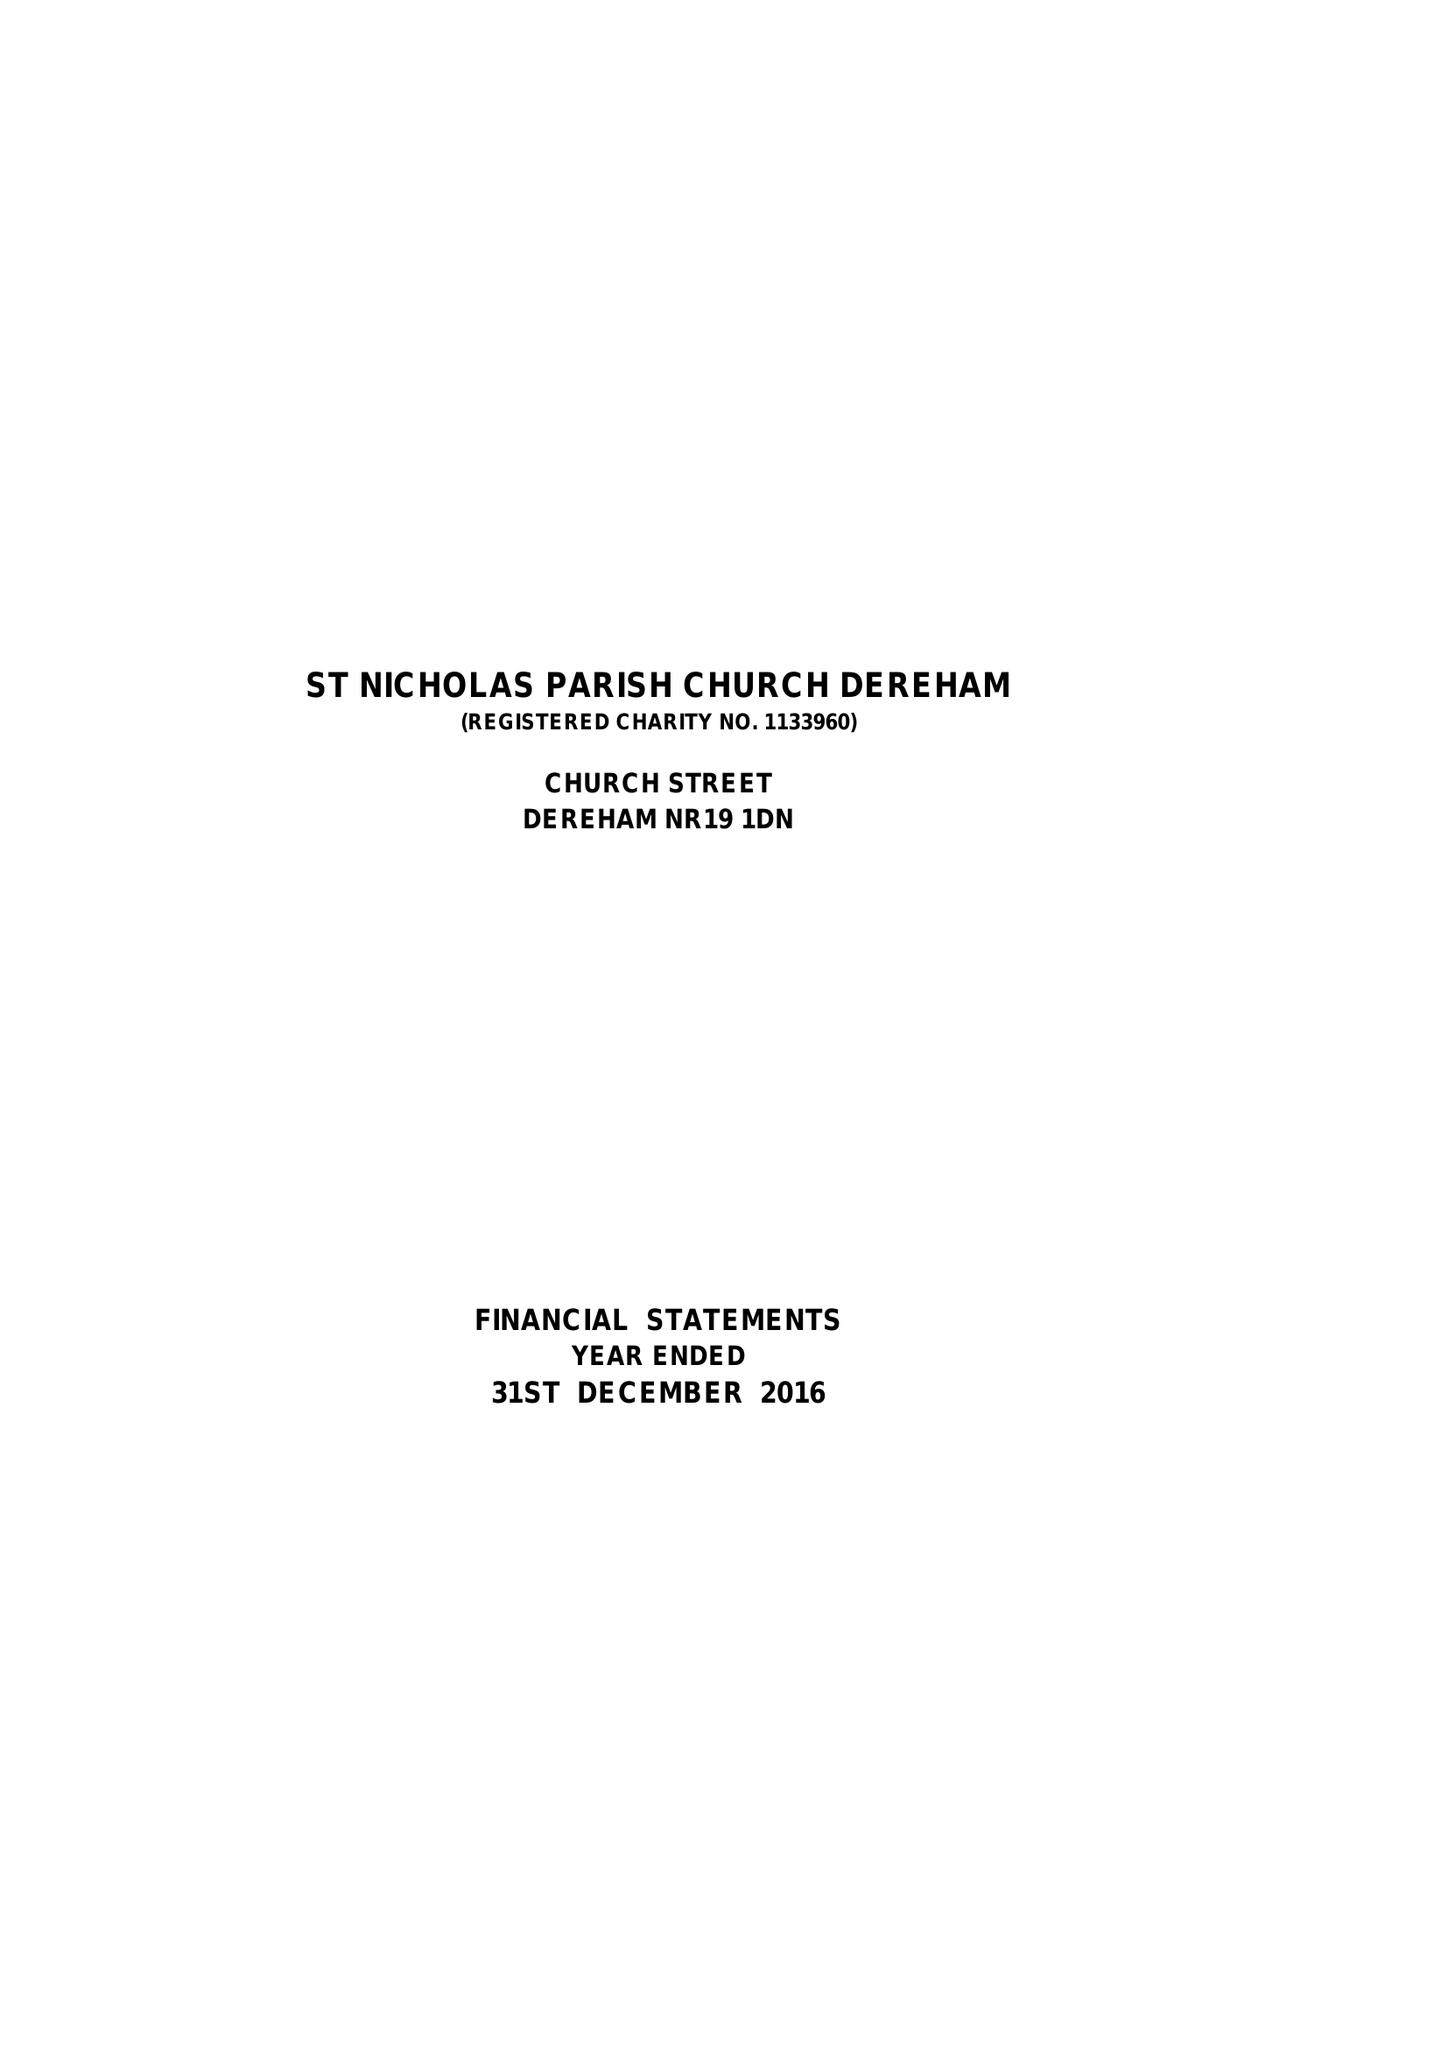What is the value for the income_annually_in_british_pounds?
Answer the question using a single word or phrase. 120926.00 